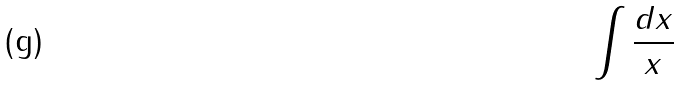Convert formula to latex. <formula><loc_0><loc_0><loc_500><loc_500>\int \frac { d x } { x }</formula> 